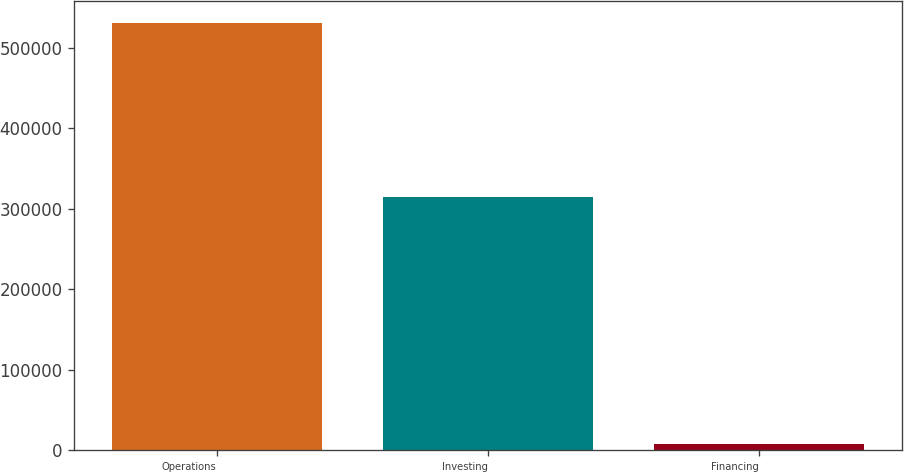<chart> <loc_0><loc_0><loc_500><loc_500><bar_chart><fcel>Operations<fcel>Investing<fcel>Financing<nl><fcel>531151<fcel>313981<fcel>7678<nl></chart> 